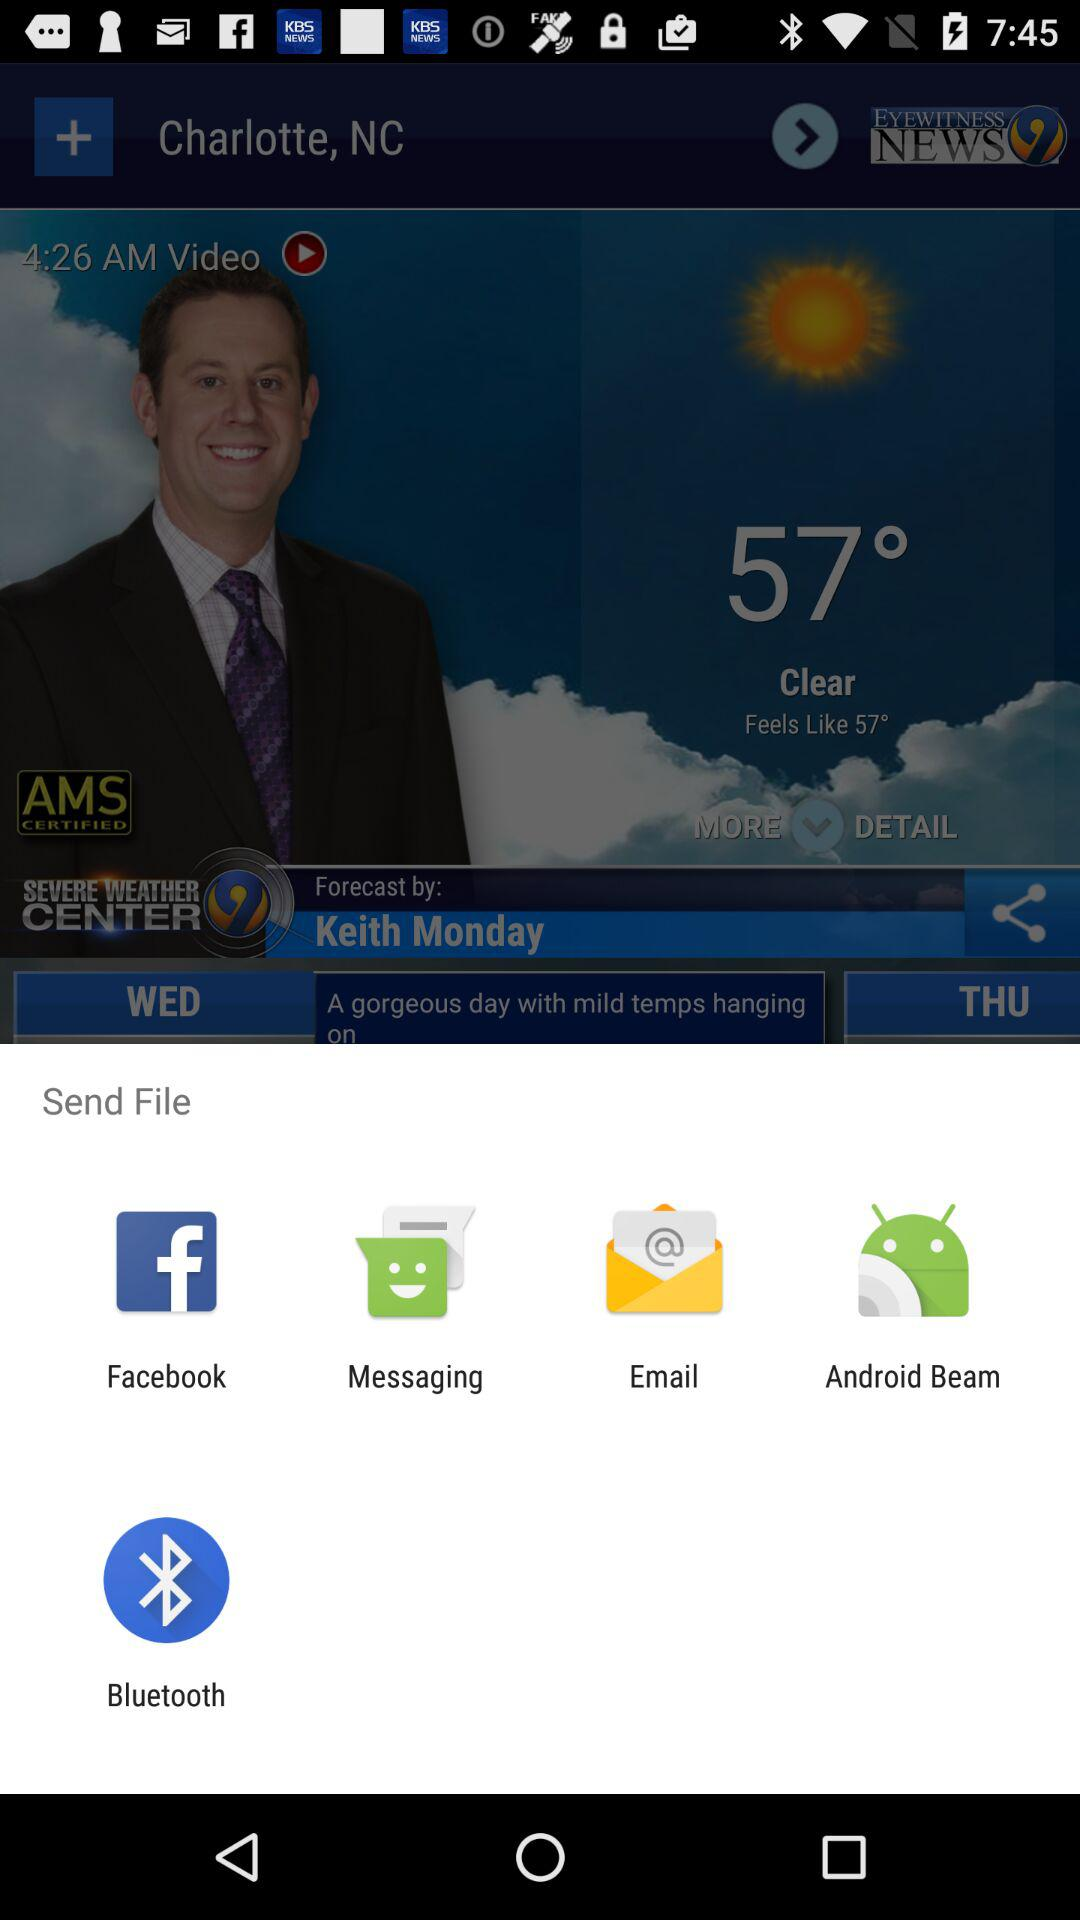What is the temperature? The temperature is 57 degrees. 